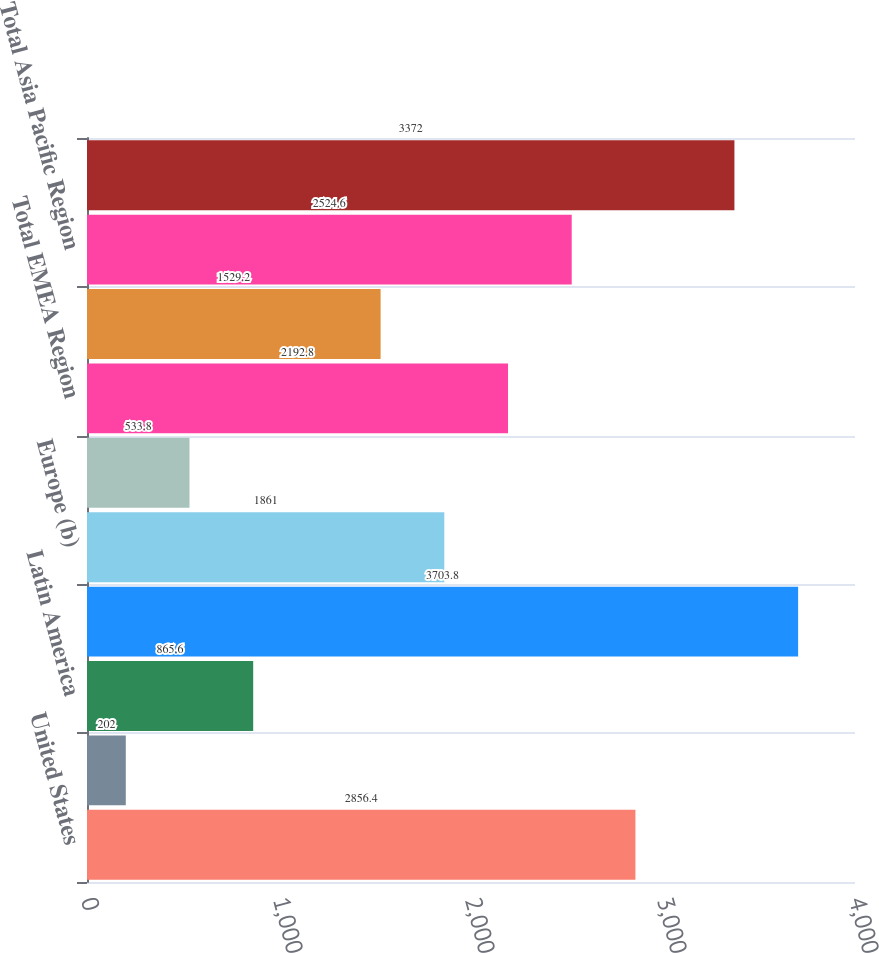<chart> <loc_0><loc_0><loc_500><loc_500><bar_chart><fcel>United States<fcel>Canada<fcel>Latin America<fcel>Total Americas Region<fcel>Europe (b)<fcel>Other<fcel>Total EMEA Region<fcel>Japan<fcel>Total Asia Pacific Region<fcel>Total Worldwide Retail Sales<nl><fcel>2856.4<fcel>202<fcel>865.6<fcel>3703.8<fcel>1861<fcel>533.8<fcel>2192.8<fcel>1529.2<fcel>2524.6<fcel>3372<nl></chart> 